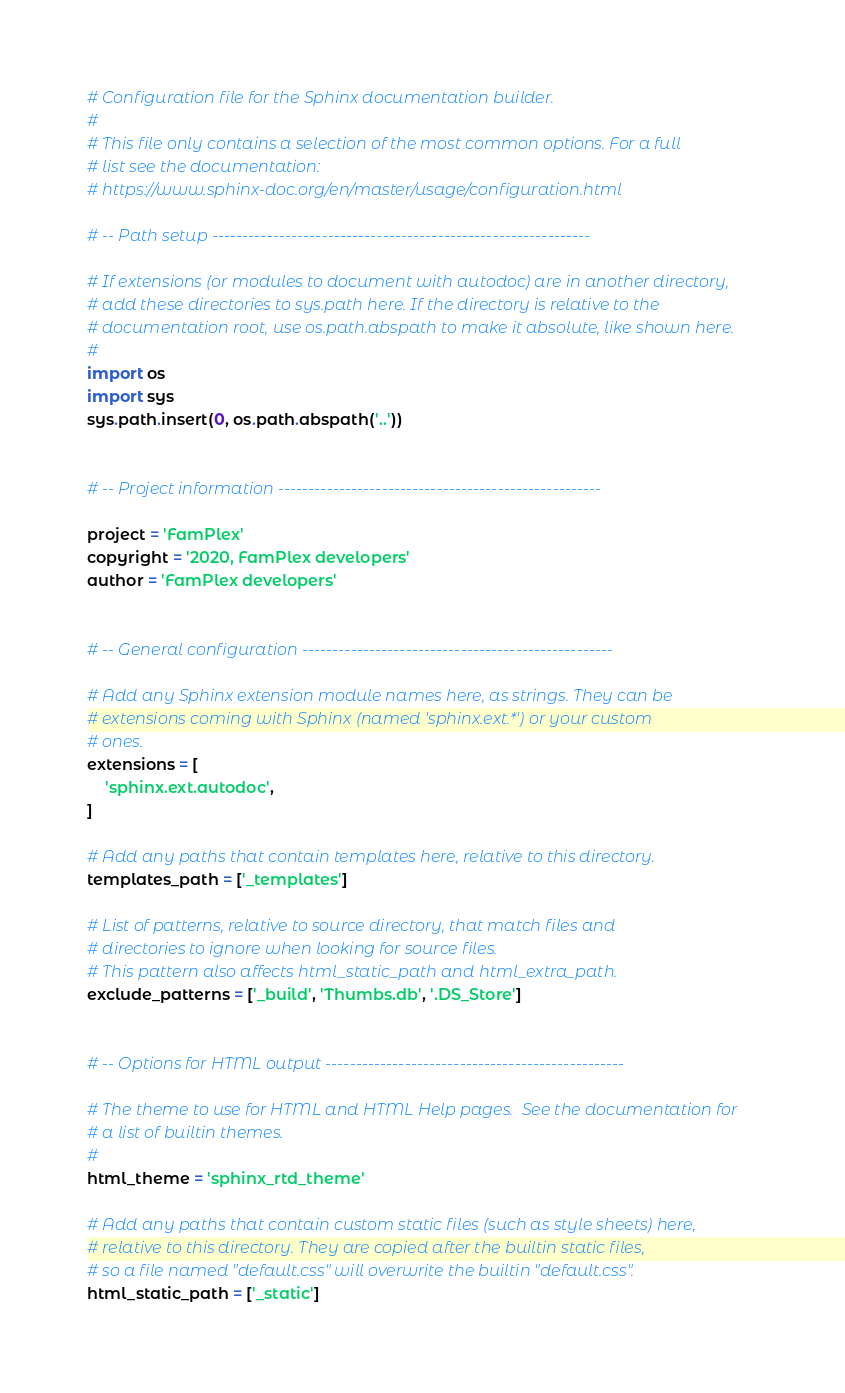Convert code to text. <code><loc_0><loc_0><loc_500><loc_500><_Python_># Configuration file for the Sphinx documentation builder.
#
# This file only contains a selection of the most common options. For a full
# list see the documentation:
# https://www.sphinx-doc.org/en/master/usage/configuration.html

# -- Path setup --------------------------------------------------------------

# If extensions (or modules to document with autodoc) are in another directory,
# add these directories to sys.path here. If the directory is relative to the
# documentation root, use os.path.abspath to make it absolute, like shown here.
#
import os
import sys
sys.path.insert(0, os.path.abspath('..'))


# -- Project information -----------------------------------------------------

project = 'FamPlex'
copyright = '2020, FamPlex developers'
author = 'FamPlex developers'


# -- General configuration ---------------------------------------------------

# Add any Sphinx extension module names here, as strings. They can be
# extensions coming with Sphinx (named 'sphinx.ext.*') or your custom
# ones.
extensions = [
    'sphinx.ext.autodoc',
]

# Add any paths that contain templates here, relative to this directory.
templates_path = ['_templates']

# List of patterns, relative to source directory, that match files and
# directories to ignore when looking for source files.
# This pattern also affects html_static_path and html_extra_path.
exclude_patterns = ['_build', 'Thumbs.db', '.DS_Store']


# -- Options for HTML output -------------------------------------------------

# The theme to use for HTML and HTML Help pages.  See the documentation for
# a list of builtin themes.
#
html_theme = 'sphinx_rtd_theme'

# Add any paths that contain custom static files (such as style sheets) here,
# relative to this directory. They are copied after the builtin static files,
# so a file named "default.css" will overwrite the builtin "default.css".
html_static_path = ['_static']
</code> 